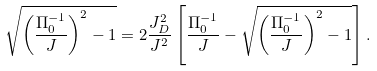<formula> <loc_0><loc_0><loc_500><loc_500>\sqrt { \left ( { \frac { \Pi _ { 0 } ^ { - 1 } } { J } } \right ) ^ { 2 } - 1 } = 2 \frac { J _ { D } ^ { 2 } } { J ^ { 2 } } \left [ { \frac { \Pi _ { 0 } ^ { - 1 } } { J } - \sqrt { \left ( { \frac { \Pi _ { 0 } ^ { - 1 } } { J } } \right ) ^ { 2 } - 1 } } \right ] .</formula> 